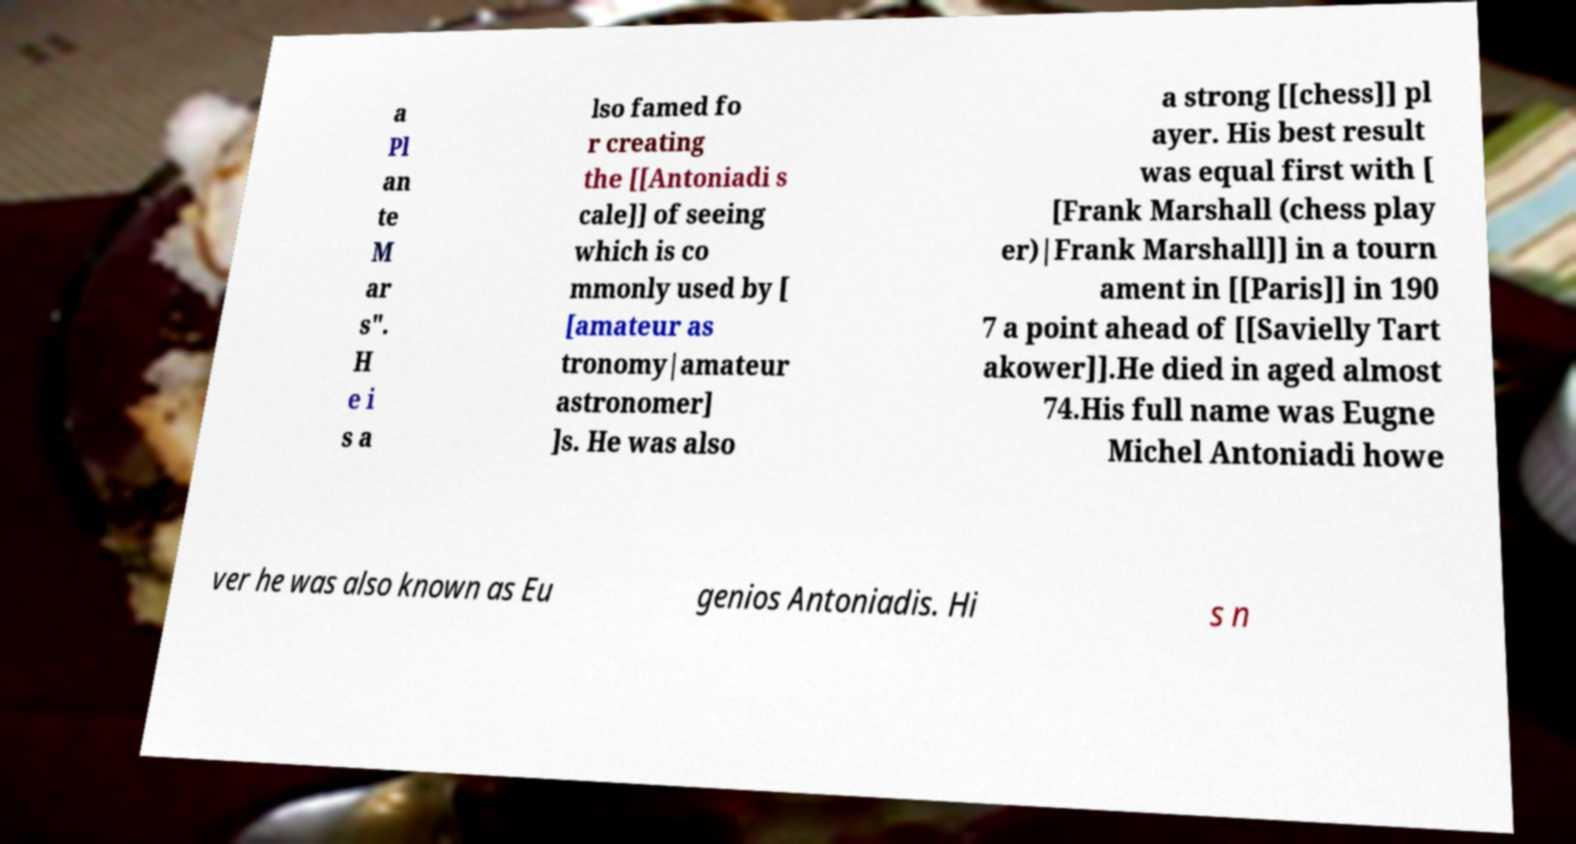Could you extract and type out the text from this image? a Pl an te M ar s". H e i s a lso famed fo r creating the [[Antoniadi s cale]] of seeing which is co mmonly used by [ [amateur as tronomy|amateur astronomer] ]s. He was also a strong [[chess]] pl ayer. His best result was equal first with [ [Frank Marshall (chess play er)|Frank Marshall]] in a tourn ament in [[Paris]] in 190 7 a point ahead of [[Savielly Tart akower]].He died in aged almost 74.His full name was Eugne Michel Antoniadi howe ver he was also known as Eu genios Antoniadis. Hi s n 